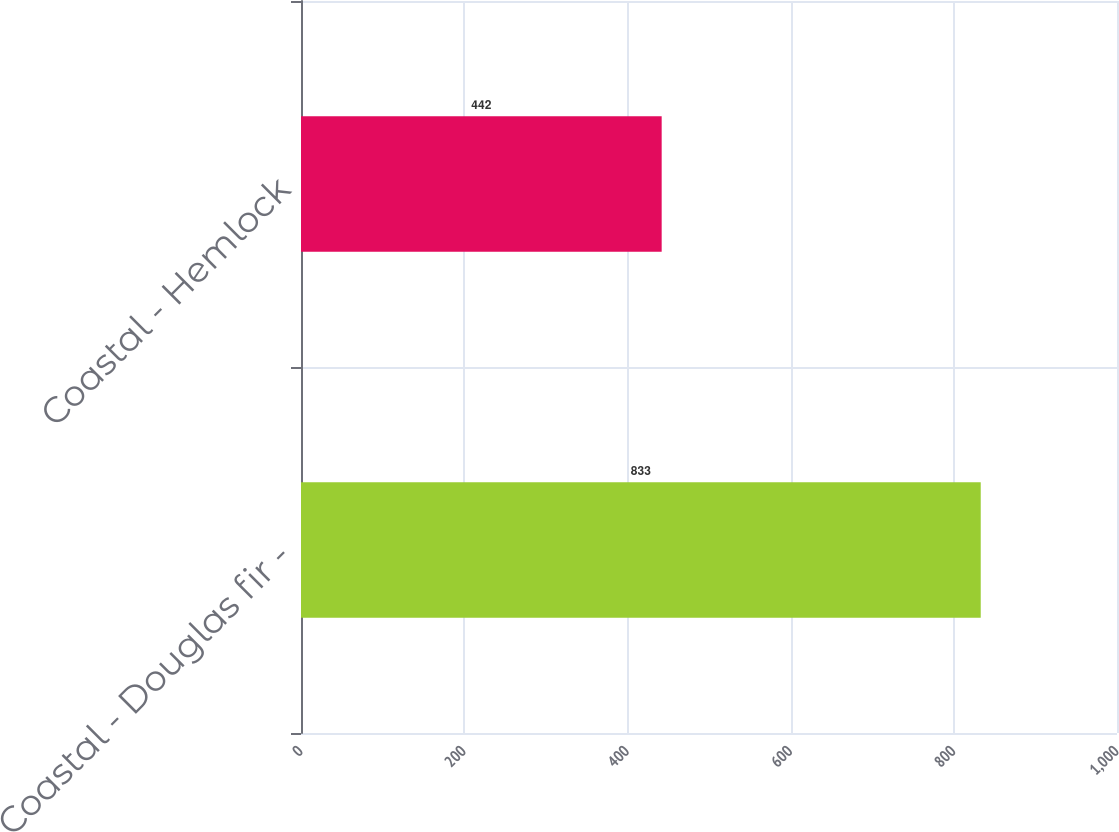Convert chart. <chart><loc_0><loc_0><loc_500><loc_500><bar_chart><fcel>Coastal - Douglas fir -<fcel>Coastal - Hemlock<nl><fcel>833<fcel>442<nl></chart> 